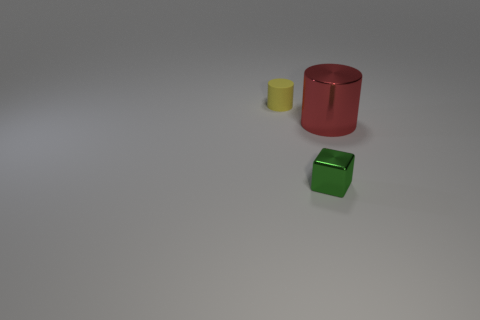Are there any blocks of the same size as the red metal cylinder? From the perspective provided in the image, there are no blocks that appear to be the exact same size as the red metal cylinder. Although the green block might seem comparable in height, its square footprint makes it distinct in size and shape compared to the cylindrical form of the red object. 